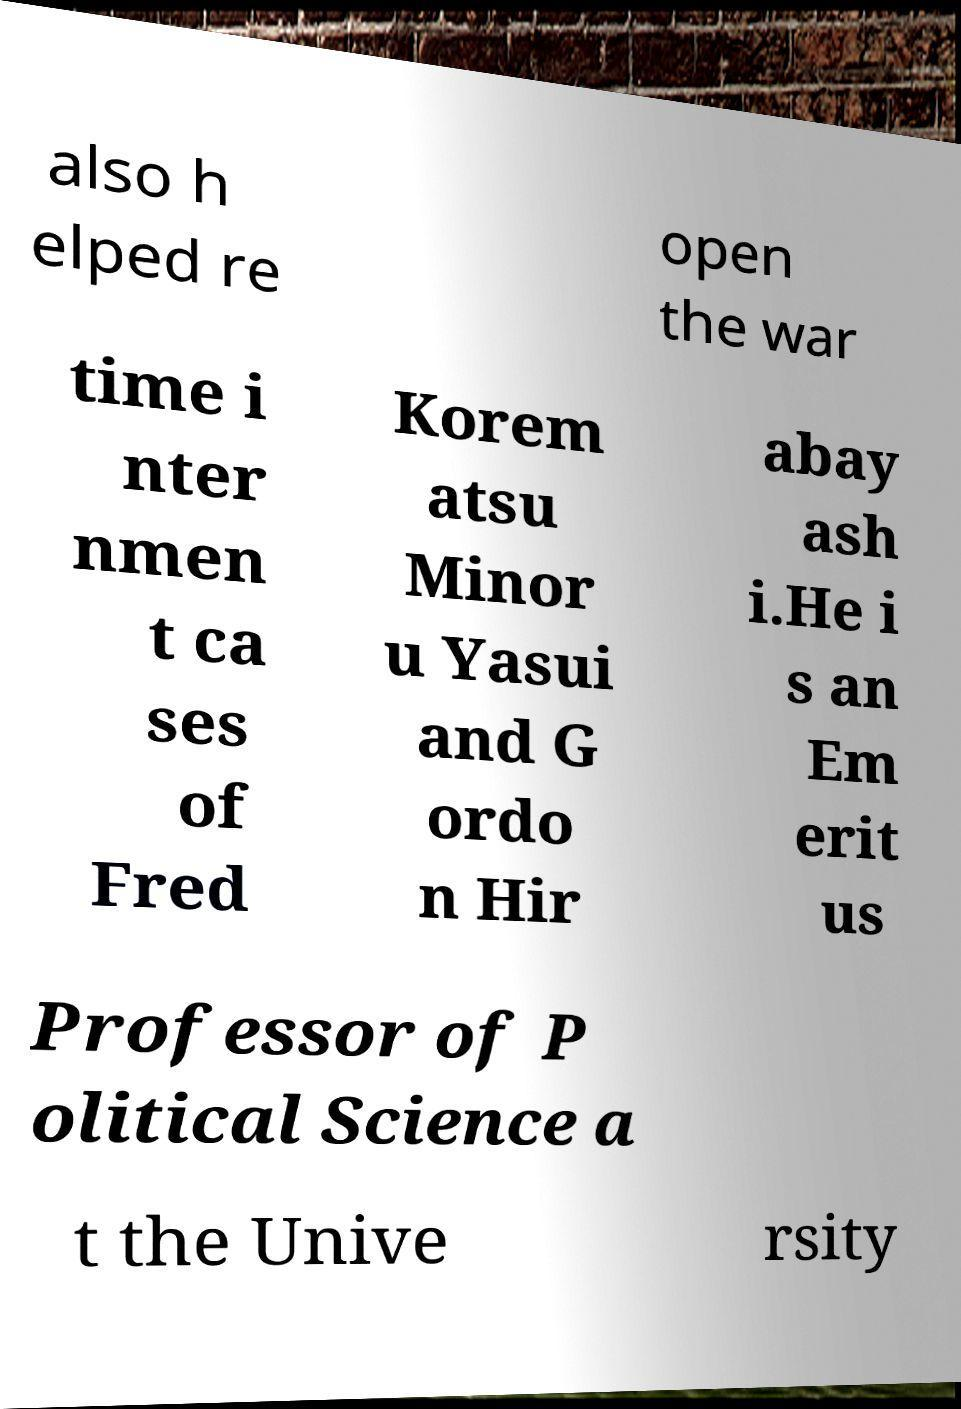Can you read and provide the text displayed in the image?This photo seems to have some interesting text. Can you extract and type it out for me? also h elped re open the war time i nter nmen t ca ses of Fred Korem atsu Minor u Yasui and G ordo n Hir abay ash i.He i s an Em erit us Professor of P olitical Science a t the Unive rsity 